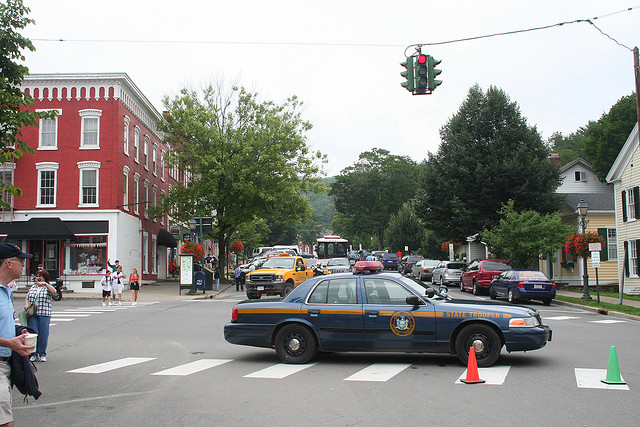Please transcribe the text information in this image. STATE 